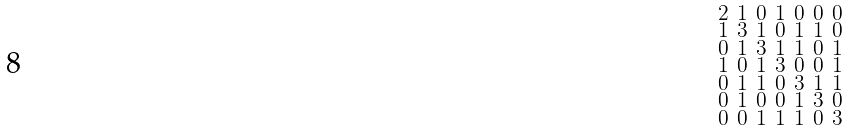<formula> <loc_0><loc_0><loc_500><loc_500>\begin{smallmatrix} 2 & 1 & 0 & 1 & 0 & 0 & 0 \\ 1 & 3 & 1 & 0 & 1 & 1 & 0 \\ 0 & 1 & 3 & 1 & 1 & 0 & 1 \\ 1 & 0 & 1 & 3 & 0 & 0 & 1 \\ 0 & 1 & 1 & 0 & 3 & 1 & 1 \\ 0 & 1 & 0 & 0 & 1 & 3 & 0 \\ 0 & 0 & 1 & 1 & 1 & 0 & 3 \end{smallmatrix}</formula> 